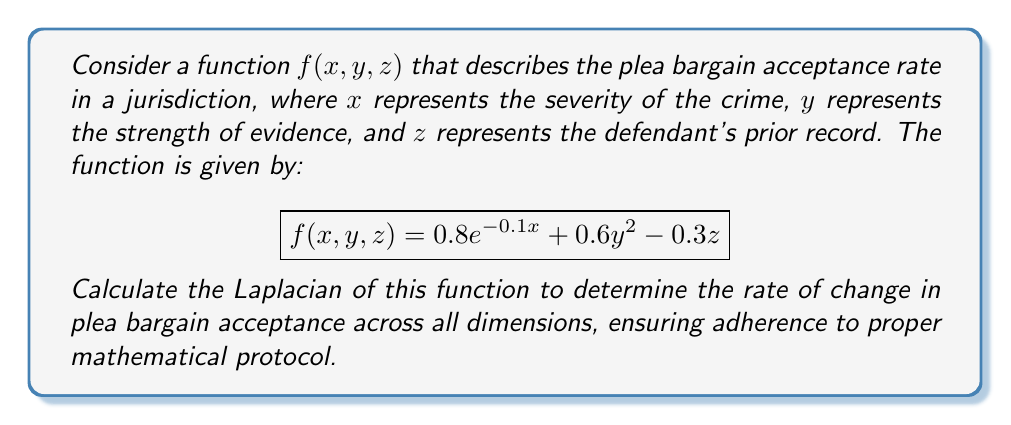Could you help me with this problem? To calculate the Laplacian of the function $f(x, y, z)$, we need to follow these steps:

1. Recall that the Laplacian in 3D Cartesian coordinates is defined as:

   $$\nabla^2f = \frac{\partial^2f}{\partial x^2} + \frac{\partial^2f}{\partial y^2} + \frac{\partial^2f}{\partial z^2}$$

2. Calculate $\frac{\partial^2f}{\partial x^2}$:
   
   First, $\frac{\partial f}{\partial x} = -0.08e^{-0.1x}$
   Then, $\frac{\partial^2f}{\partial x^2} = 0.008e^{-0.1x}$

3. Calculate $\frac{\partial^2f}{\partial y^2}$:
   
   First, $\frac{\partial f}{\partial y} = 1.2y$
   Then, $\frac{\partial^2f}{\partial y^2} = 1.2$

4. Calculate $\frac{\partial^2f}{\partial z^2}$:
   
   $\frac{\partial f}{\partial z} = -0.3$
   $\frac{\partial^2f}{\partial z^2} = 0$

5. Sum the second partial derivatives:

   $$\nabla^2f = 0.008e^{-0.1x} + 1.2 + 0 = 0.008e^{-0.1x} + 1.2$$

This result represents the rate of change in plea bargain acceptance across all dimensions, adhering to the mathematical protocol for calculating the Laplacian.
Answer: $$\nabla^2f = 0.008e^{-0.1x} + 1.2$$ 